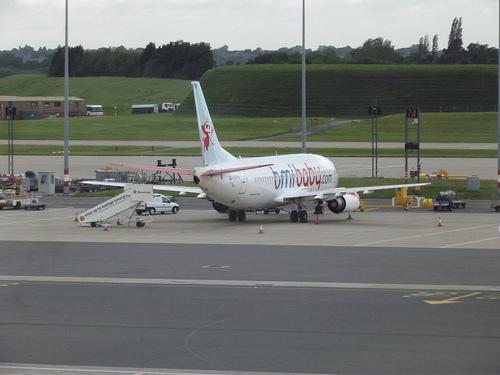Question: what is white?
Choices:
A. Plane.
B. The person.
C. The cat.
D. The dog.
Answer with the letter. Answer: A Question: what is green?
Choices:
A. Several plants.
B. Sick people.
C. Diarrhea.
D. Grass.
Answer with the letter. Answer: D Question: why does the plane have wings?
Choices:
A. To fly.
B. To make the air pressure higher under the plane.
C. To make the air pressure lower above the plane.
D. To achieve lift.
Answer with the letter. Answer: A Question: what has wings?
Choices:
A. Birds.
B. The plane.
C. Bats.
D. Insects.
Answer with the letter. Answer: B Question: where is the plane?
Choices:
A. The air.
B. At an airport.
C. Backyard.
D. In a tree.
Answer with the letter. Answer: B Question: where are trees?
Choices:
A. Next to the camel.
B. Beside the person.
C. In the distance.
D. Underneath the jaguar.
Answer with the letter. Answer: C 